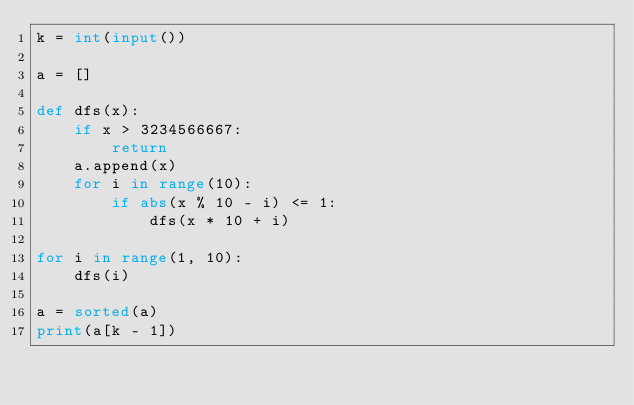<code> <loc_0><loc_0><loc_500><loc_500><_Python_>k = int(input())

a = []

def dfs(x):
    if x > 3234566667:
        return
    a.append(x)
    for i in range(10):
        if abs(x % 10 - i) <= 1:
            dfs(x * 10 + i)

for i in range(1, 10):
    dfs(i)

a = sorted(a)
print(a[k - 1])
</code> 